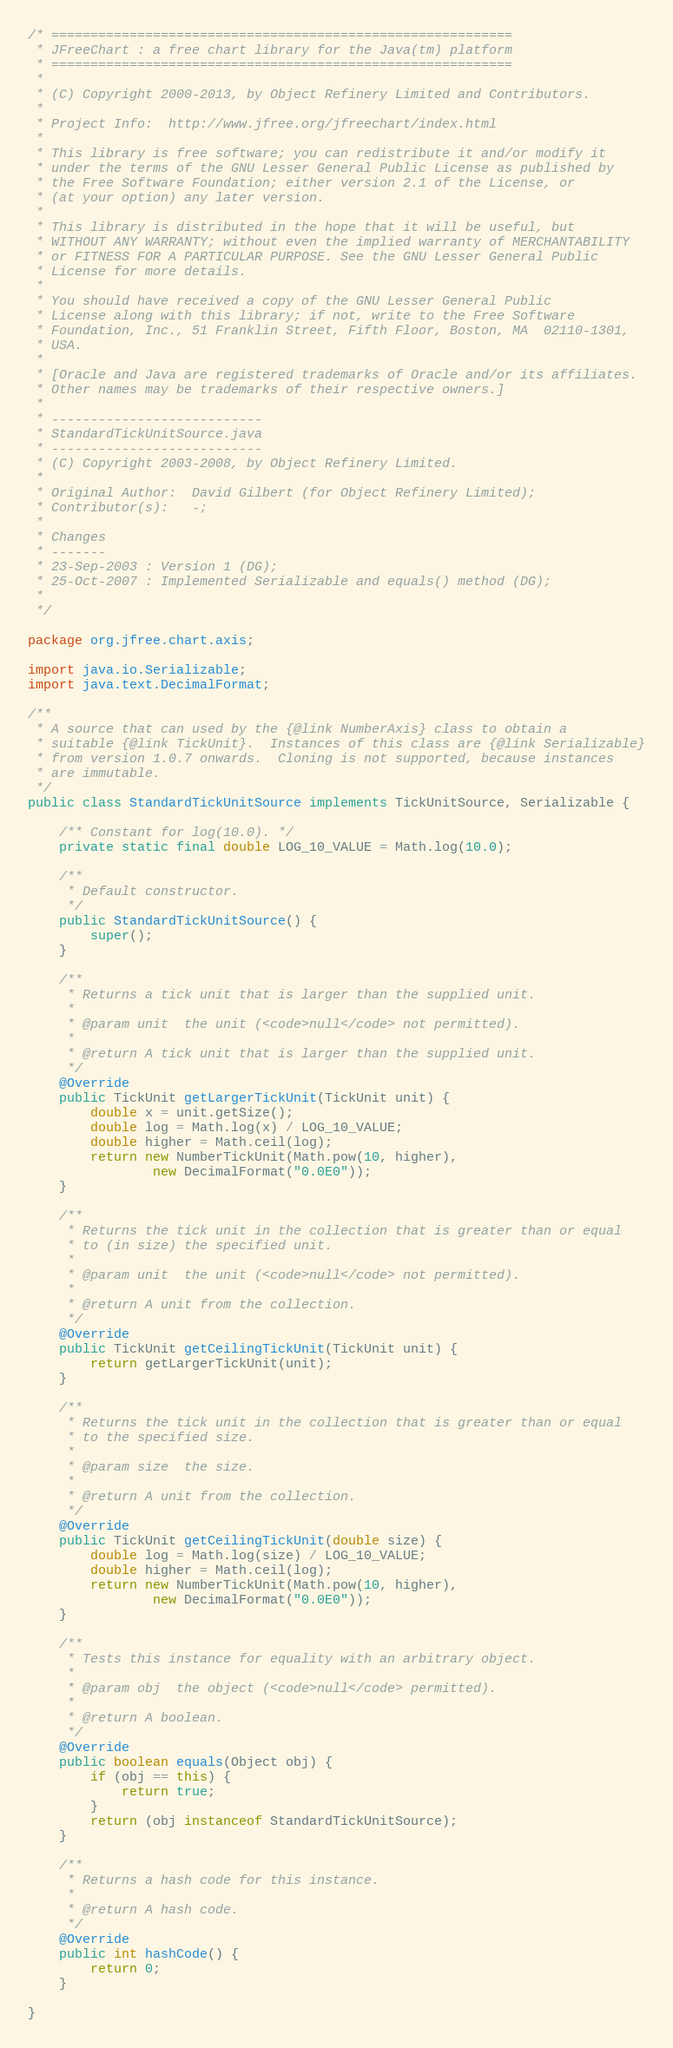<code> <loc_0><loc_0><loc_500><loc_500><_Java_>/* ===========================================================
 * JFreeChart : a free chart library for the Java(tm) platform
 * ===========================================================
 *
 * (C) Copyright 2000-2013, by Object Refinery Limited and Contributors.
 *
 * Project Info:  http://www.jfree.org/jfreechart/index.html
 *
 * This library is free software; you can redistribute it and/or modify it
 * under the terms of the GNU Lesser General Public License as published by
 * the Free Software Foundation; either version 2.1 of the License, or
 * (at your option) any later version.
 *
 * This library is distributed in the hope that it will be useful, but
 * WITHOUT ANY WARRANTY; without even the implied warranty of MERCHANTABILITY
 * or FITNESS FOR A PARTICULAR PURPOSE. See the GNU Lesser General Public
 * License for more details.
 *
 * You should have received a copy of the GNU Lesser General Public
 * License along with this library; if not, write to the Free Software
 * Foundation, Inc., 51 Franklin Street, Fifth Floor, Boston, MA  02110-1301,
 * USA.
 *
 * [Oracle and Java are registered trademarks of Oracle and/or its affiliates. 
 * Other names may be trademarks of their respective owners.]
 *
 * ---------------------------
 * StandardTickUnitSource.java
 * ---------------------------
 * (C) Copyright 2003-2008, by Object Refinery Limited.
 *
 * Original Author:  David Gilbert (for Object Refinery Limited);
 * Contributor(s):   -;
 *
 * Changes
 * -------
 * 23-Sep-2003 : Version 1 (DG);
 * 25-Oct-2007 : Implemented Serializable and equals() method (DG);
 *
 */

package org.jfree.chart.axis;

import java.io.Serializable;
import java.text.DecimalFormat;

/**
 * A source that can used by the {@link NumberAxis} class to obtain a
 * suitable {@link TickUnit}.  Instances of this class are {@link Serializable}
 * from version 1.0.7 onwards.  Cloning is not supported, because instances
 * are immutable.
 */
public class StandardTickUnitSource implements TickUnitSource, Serializable {

    /** Constant for log(10.0). */
    private static final double LOG_10_VALUE = Math.log(10.0);

    /**
     * Default constructor.
     */
    public StandardTickUnitSource() {
        super();
    }

    /**
     * Returns a tick unit that is larger than the supplied unit.
     *
     * @param unit  the unit (<code>null</code> not permitted).
     *
     * @return A tick unit that is larger than the supplied unit.
     */
    @Override
    public TickUnit getLargerTickUnit(TickUnit unit) {
        double x = unit.getSize();
        double log = Math.log(x) / LOG_10_VALUE;
        double higher = Math.ceil(log);
        return new NumberTickUnit(Math.pow(10, higher),
                new DecimalFormat("0.0E0"));
    }

    /**
     * Returns the tick unit in the collection that is greater than or equal
     * to (in size) the specified unit.
     *
     * @param unit  the unit (<code>null</code> not permitted).
     *
     * @return A unit from the collection.
     */
    @Override
    public TickUnit getCeilingTickUnit(TickUnit unit) {
        return getLargerTickUnit(unit);
    }

    /**
     * Returns the tick unit in the collection that is greater than or equal
     * to the specified size.
     *
     * @param size  the size.
     *
     * @return A unit from the collection.
     */
    @Override
    public TickUnit getCeilingTickUnit(double size) {
        double log = Math.log(size) / LOG_10_VALUE;
        double higher = Math.ceil(log);
        return new NumberTickUnit(Math.pow(10, higher),
                new DecimalFormat("0.0E0"));
    }

    /**
     * Tests this instance for equality with an arbitrary object.
     *
     * @param obj  the object (<code>null</code> permitted).
     *
     * @return A boolean.
     */
    @Override
    public boolean equals(Object obj) {
        if (obj == this) {
            return true;
        }
        return (obj instanceof StandardTickUnitSource);
    }

    /**
     * Returns a hash code for this instance.
     *
     * @return A hash code.
     */
    @Override
    public int hashCode() {
        return 0;
    }

}
</code> 